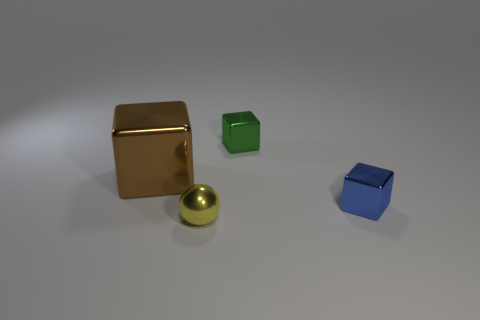How many blue metal blocks have the same size as the yellow metallic thing?
Your answer should be very brief. 1. There is a tiny green thing that is the same shape as the tiny blue thing; what is its material?
Your answer should be compact. Metal. Do the shiny block behind the large metal cube and the block in front of the large brown object have the same color?
Provide a succinct answer. No. There is a metal thing that is in front of the blue object; what shape is it?
Offer a very short reply. Sphere. The large object is what color?
Your answer should be very brief. Brown. The tiny green object that is the same material as the blue block is what shape?
Give a very brief answer. Cube. Does the cube that is left of the yellow metallic ball have the same size as the tiny green block?
Your answer should be compact. No. What number of things are yellow things right of the big brown cube or shiny cubes left of the small blue block?
Your answer should be very brief. 3. There is a tiny object that is behind the tiny blue cube; is it the same color as the large cube?
Ensure brevity in your answer.  No. What number of metallic things are either tiny cubes or large brown cubes?
Your answer should be very brief. 3. 